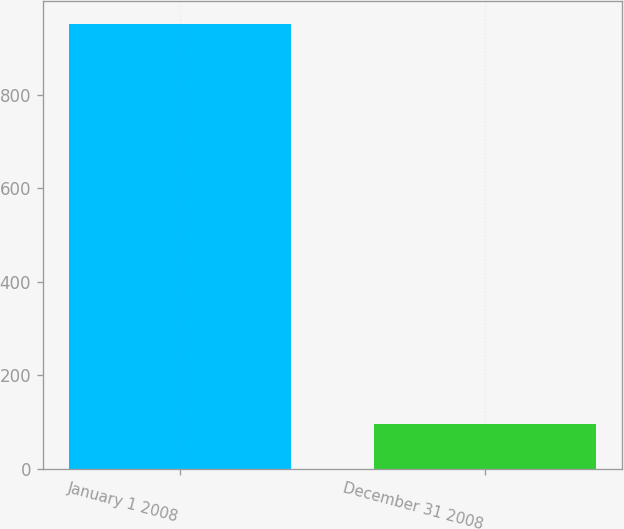Convert chart. <chart><loc_0><loc_0><loc_500><loc_500><bar_chart><fcel>January 1 2008<fcel>December 31 2008<nl><fcel>952.1<fcel>95.8<nl></chart> 